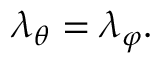<formula> <loc_0><loc_0><loc_500><loc_500>\lambda _ { \theta } = \lambda _ { \varphi } .</formula> 